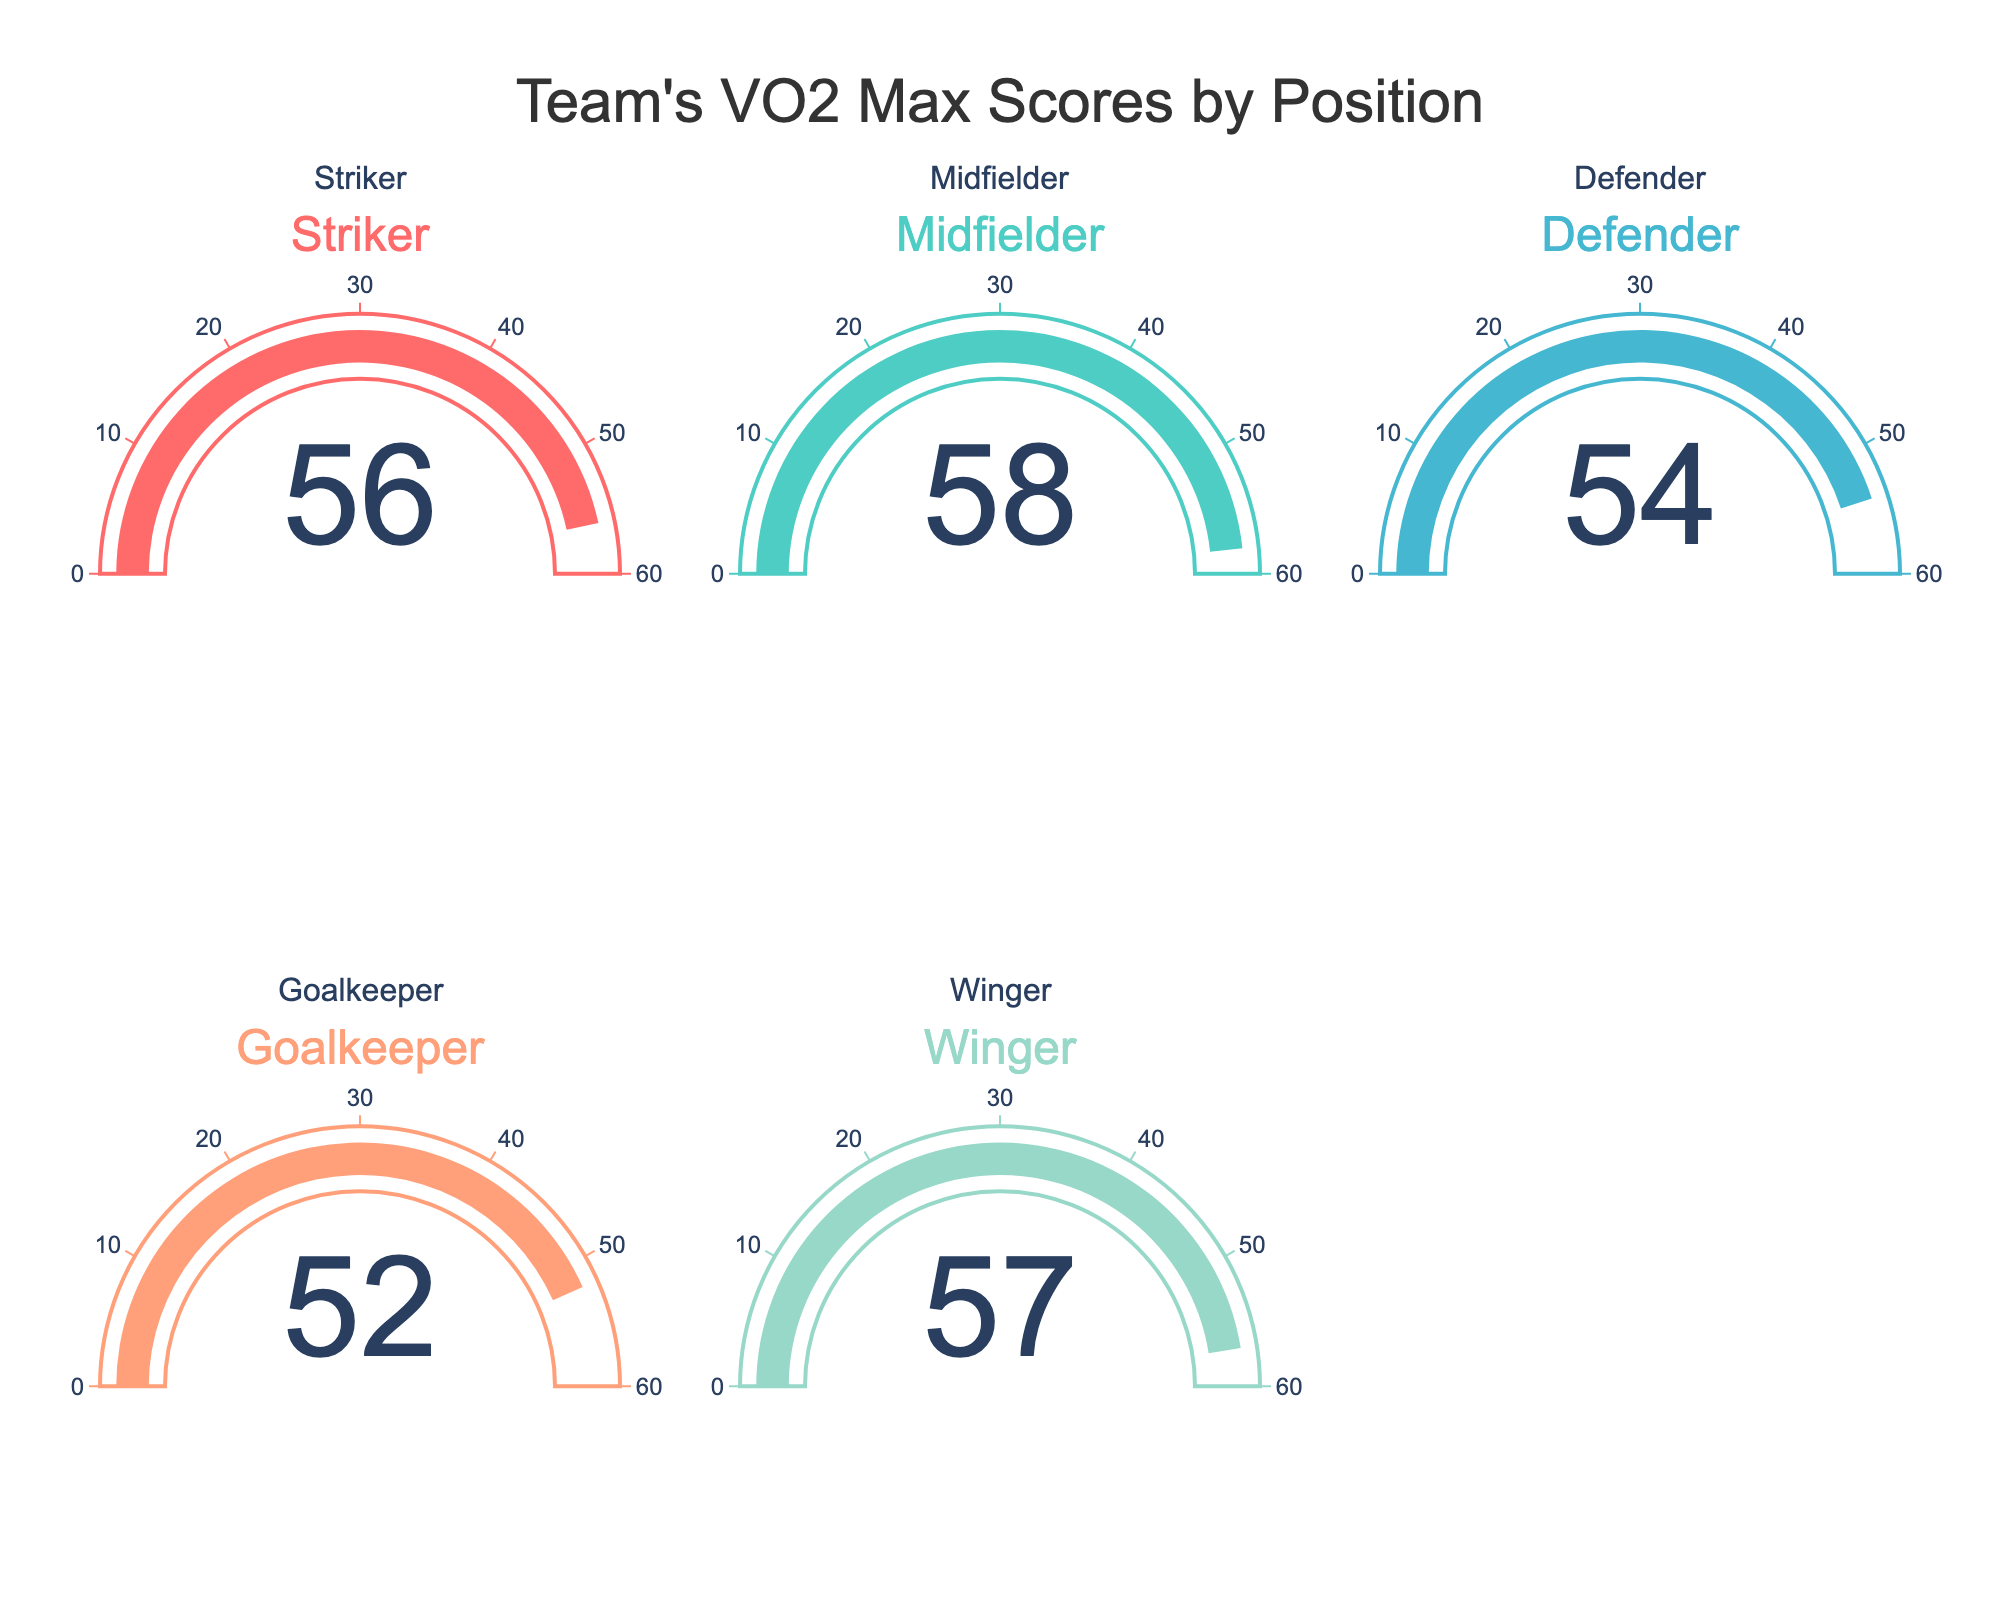What's the VO2 Max score for the Striker? Look at the gauge chart labeled "Striker" and identify the number displayed in the middle of the chart.
Answer: 56 Which position has the highest VO2 Max score? Compare the values displayed on each gauge. The Midfielder has a score of 58, which is higher than the scores for the Striker, Defender, Goalkeeper, and Winger.
Answer: Midfielder What's the average VO2 Max score across all positions? Add up all the scores (56 + 58 + 54 + 52 + 57) to get 277. Then, divide by the number of positions, which is 5. The average is 277 / 5.
Answer: 55.4 How does the Goalkeeper's VO2 Max score compare to the Defender's? Look at the values for both positions: the Goalkeeper has a score of 52, and the Defender has a score of 54. Compare these two values.
Answer: Goalkeeper's score is lower Which two positions have the closest VO2 Max scores? Look at the values for each position: Striker (56), Midfielder (58), Defender (54), Goalkeeper (52), and Winger (57). Observe that the Striker and Winger have scores of 56 and 57 respectively, which are the closest.
Answer: Striker and Winger What's the range of VO2 Max scores in the team? Identify the highest VO2 Max score (58 for Midfielder) and the lowest VO2 Max score (52 for Goalkeeper). Subtract the lowest score from the highest score to find the range: 58 - 52.
Answer: 6 If you combine the VO2 Max scores for the Striker and Defender, what would be the total? Add the scores for both positions: Striker (56) and Defender (54). 56 + 54 equals 110.
Answer: 110 How much higher is the Midfielder's score compared to the Goalkeeper's? Subtract the Goalkeeper's score (52) from the Midfielder's score (58): 58 - 52 equals 6.
Answer: 6 Which position is in the bottom 25% of the VO2 Max scores? To find the bottom 25%, we first need to sort the scores (52, 54, 56, 57, 58). Given there are 5 scores, the bottom 25% would include the lowest score or the lowest 1.25 (25% of 5); here, it is the lowest score directly, which is the Goalkeeper's.
Answer: Goalkeeper What's the median VO2 Max score of the team? Arrange the scores in increasing order: 52, 54, 56, 57, 58. The median is the middle value, which in this case is the third score.
Answer: 56 